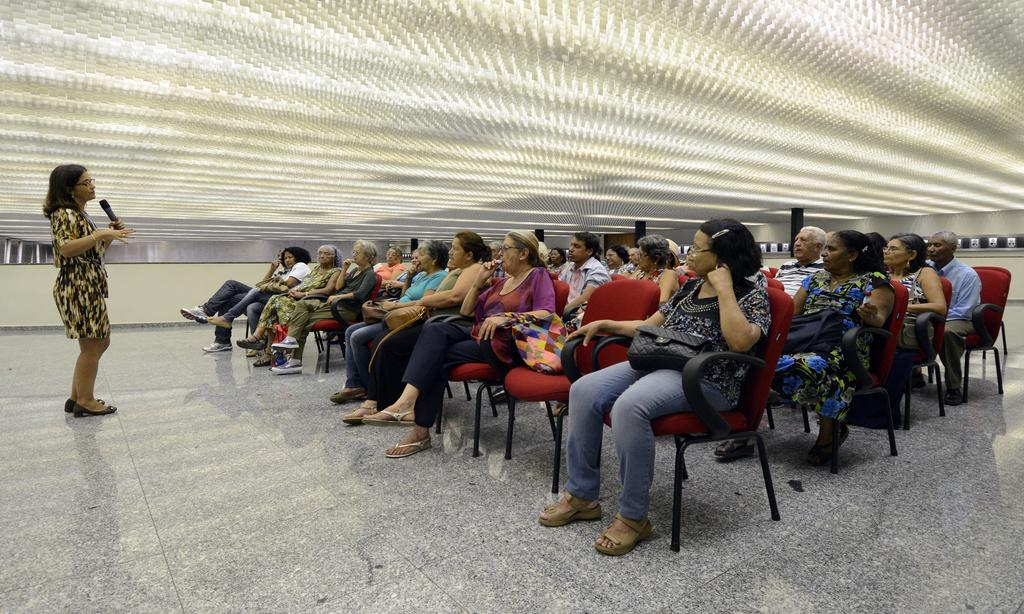What is happening in the image involving a group of people? The people in the image are sitting and listening to a lecture. Can you describe the setting of the image? There is a white roofing visible at the top of the image. What might be the purpose of the people sitting and listening? The people are likely attending a lecture or presentation to learn or gain information. What is the home of the people in the image? The image does not provide information about the home of the people; it only shows them sitting and listening to a lecture. 